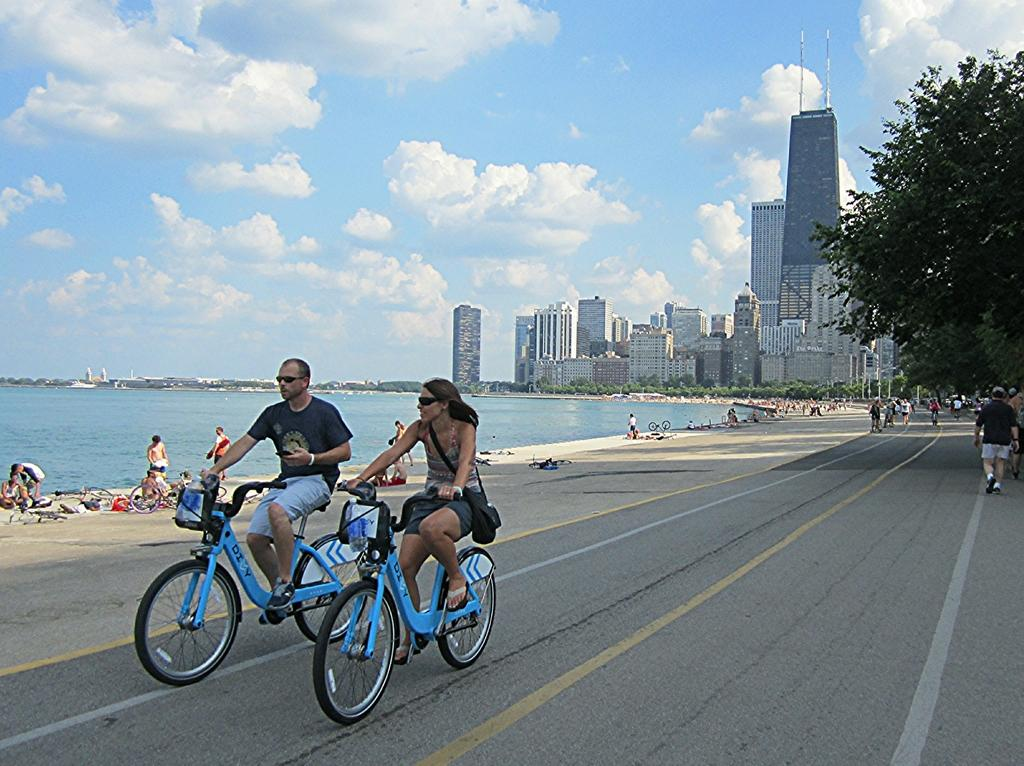What are the people in the image doing? There are persons walking on the road and riding bicycles, while others are sitting on the sea shore. What can be seen near the sea shore? The sea is visible in the image. What structures are present in the image? There are buildings in the image. What type of vegetation is present in the image? Trees are present in the image. What is visible in the sky? The sky is visible in the image, and clouds are present. What type of cherry is being used as a mode of transport in the image? There is no cherry present in the image, and therefore no such mode of transport can be observed. 